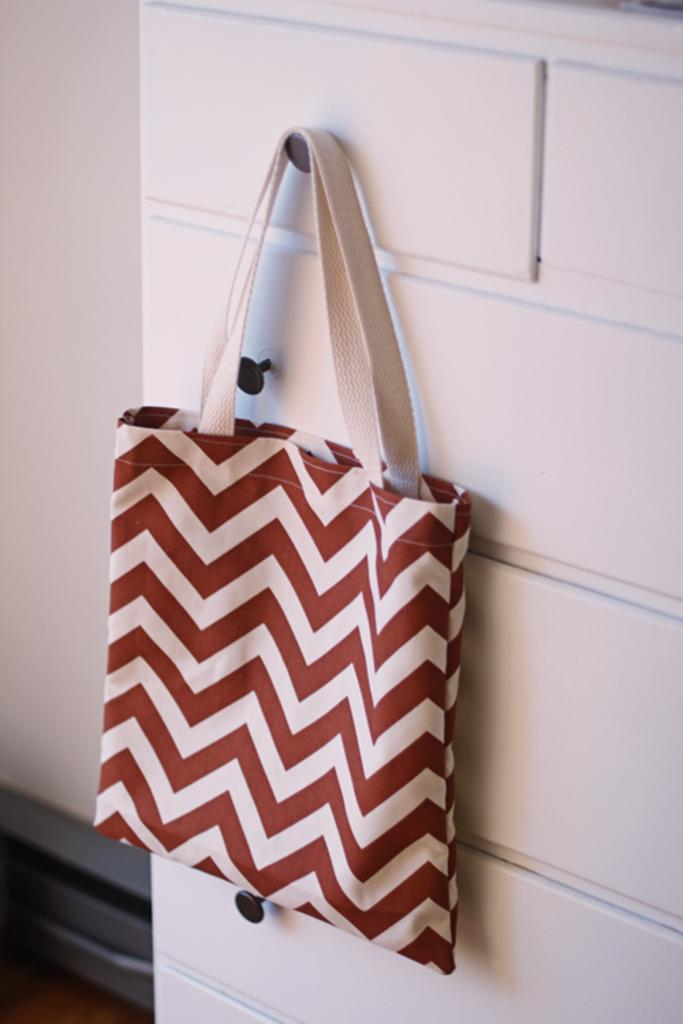What object can be seen in the image? There is a bag in the image. Where is the bag located in the image? The bag is hanging on the wall. What type of train is passing by in the image? There is no train present in the image; it only features a bag hanging on the wall. 